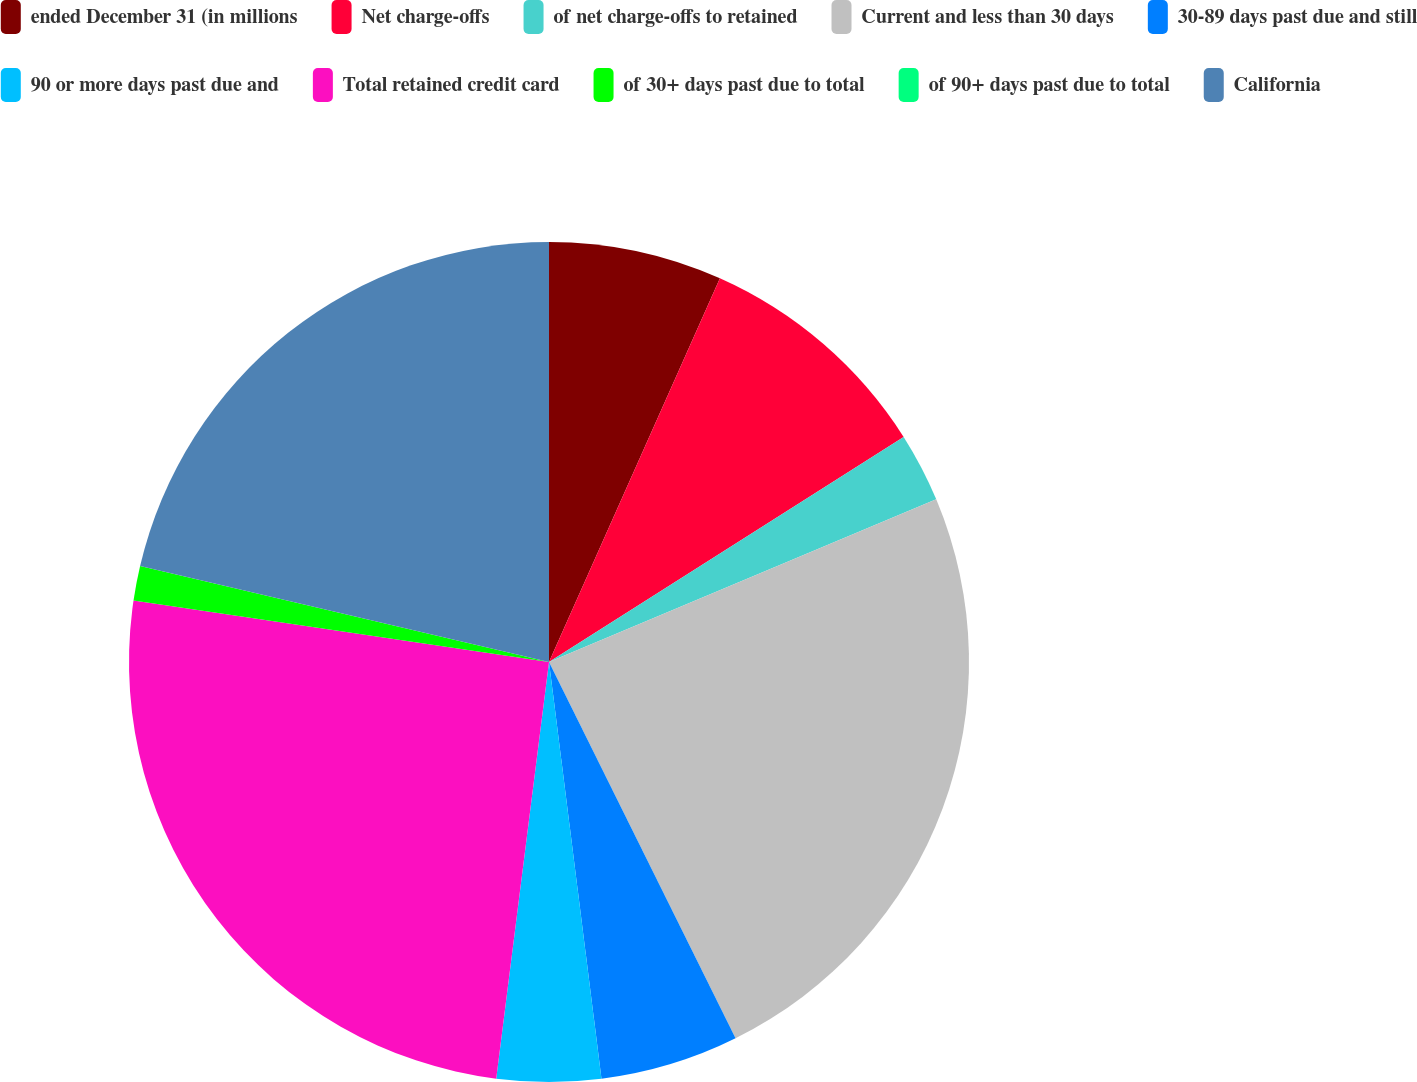<chart> <loc_0><loc_0><loc_500><loc_500><pie_chart><fcel>ended December 31 (in millions<fcel>Net charge-offs<fcel>of net charge-offs to retained<fcel>Current and less than 30 days<fcel>30-89 days past due and still<fcel>90 or more days past due and<fcel>Total retained credit card<fcel>of 30+ days past due to total<fcel>of 90+ days past due to total<fcel>California<nl><fcel>6.67%<fcel>9.33%<fcel>2.67%<fcel>24.0%<fcel>5.33%<fcel>4.0%<fcel>25.33%<fcel>1.33%<fcel>0.0%<fcel>21.33%<nl></chart> 